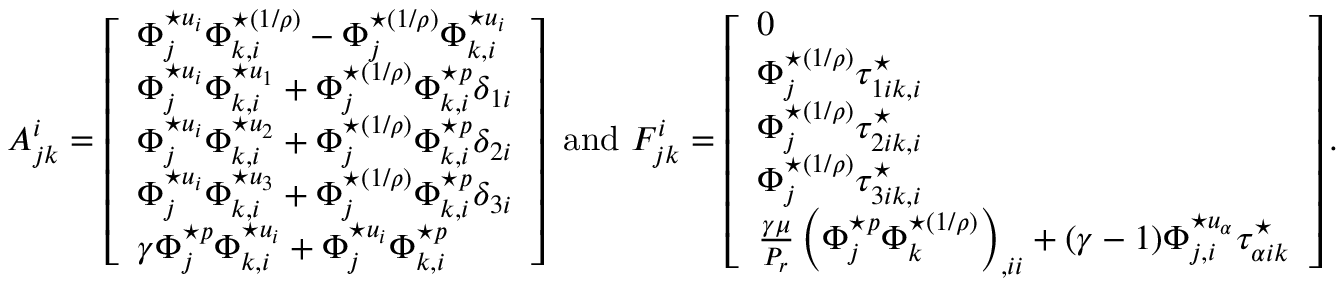<formula> <loc_0><loc_0><loc_500><loc_500>A _ { j k } ^ { i } = \left [ \begin{array} { l } { \Phi _ { j } ^ { ^ { * } u _ { i } } \Phi _ { k , i } ^ { ^ { * } ( 1 / \rho ) } - \Phi _ { j } ^ { ^ { * } ( 1 / \rho ) } \Phi _ { k , i } ^ { ^ { * } u _ { i } } } \\ { \Phi _ { j } ^ { ^ { * } u _ { i } } \Phi _ { k , i } ^ { ^ { * } u _ { 1 } } + \Phi _ { j } ^ { ^ { * } ( 1 / \rho ) } \Phi _ { k , i } ^ { ^ { * } p } \delta _ { 1 i } } \\ { \Phi _ { j } ^ { ^ { * } u _ { i } } \Phi _ { k , i } ^ { ^ { * } u _ { 2 } } + \Phi _ { j } ^ { ^ { * } ( 1 / \rho ) } \Phi _ { k , i } ^ { ^ { * } p } \delta _ { 2 i } } \\ { \Phi _ { j } ^ { ^ { * } u _ { i } } \Phi _ { k , i } ^ { ^ { * } u _ { 3 } } + \Phi _ { j } ^ { ^ { * } ( 1 / \rho ) } \Phi _ { k , i } ^ { ^ { * } p } \delta _ { 3 i } } \\ { \gamma \Phi _ { j } ^ { ^ { * } p } \Phi _ { k , i } ^ { ^ { * } u _ { i } } + \Phi _ { j } ^ { ^ { * } u _ { i } } \Phi _ { k , i } ^ { ^ { * } p } } \end{array} \right ] a n d F _ { j k } ^ { i } = \left [ \begin{array} { l } { 0 } \\ { \Phi _ { j } ^ { ^ { * } ( 1 / \rho ) } \tau _ { 1 i k , i } ^ { ^ { * } } } \\ { \Phi _ { j } ^ { ^ { * } ( 1 / \rho ) } \tau _ { 2 i k , i } ^ { ^ { * } } } \\ { \Phi _ { j } ^ { ^ { * } ( 1 / \rho ) } \tau _ { 3 i k , i } ^ { ^ { * } } } \\ { \frac { \gamma \mu } { P _ { r } } \left ( \Phi _ { j } ^ { ^ { * } p } \Phi _ { k } ^ { ^ { * } ( 1 / \rho ) } \right ) _ { , i i } + ( \gamma - 1 ) \Phi _ { j , i } ^ { ^ { * } u _ { \alpha } } \tau _ { \alpha i k } ^ { ^ { * } } } \end{array} \right ] .</formula> 